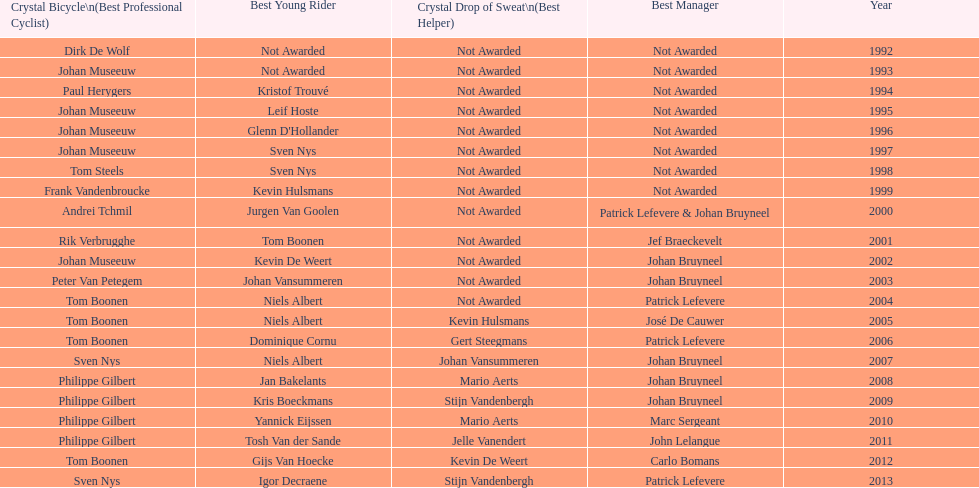Earlier, who was the winner of the crystal bicycle - boonen or nys? Tom Boonen. 